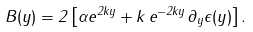<formula> <loc_0><loc_0><loc_500><loc_500>B ( y ) = 2 \left [ \alpha e ^ { 2 k y } + k \, e ^ { - 2 k y } \, \partial _ { y } \epsilon ( y ) \right ] .</formula> 